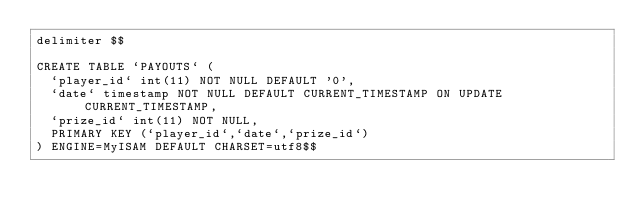<code> <loc_0><loc_0><loc_500><loc_500><_SQL_>delimiter $$

CREATE TABLE `PAYOUTS` (
  `player_id` int(11) NOT NULL DEFAULT '0',
  `date` timestamp NOT NULL DEFAULT CURRENT_TIMESTAMP ON UPDATE CURRENT_TIMESTAMP,
  `prize_id` int(11) NOT NULL,
  PRIMARY KEY (`player_id`,`date`,`prize_id`)
) ENGINE=MyISAM DEFAULT CHARSET=utf8$$


</code> 